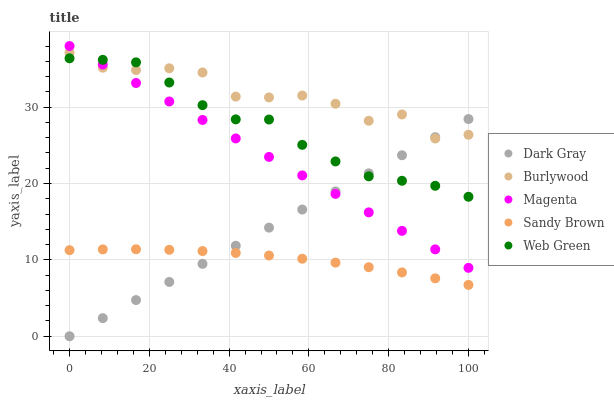Does Sandy Brown have the minimum area under the curve?
Answer yes or no. Yes. Does Burlywood have the maximum area under the curve?
Answer yes or no. Yes. Does Magenta have the minimum area under the curve?
Answer yes or no. No. Does Magenta have the maximum area under the curve?
Answer yes or no. No. Is Magenta the smoothest?
Answer yes or no. Yes. Is Burlywood the roughest?
Answer yes or no. Yes. Is Burlywood the smoothest?
Answer yes or no. No. Is Magenta the roughest?
Answer yes or no. No. Does Dark Gray have the lowest value?
Answer yes or no. Yes. Does Magenta have the lowest value?
Answer yes or no. No. Does Magenta have the highest value?
Answer yes or no. Yes. Does Burlywood have the highest value?
Answer yes or no. No. Is Sandy Brown less than Web Green?
Answer yes or no. Yes. Is Web Green greater than Sandy Brown?
Answer yes or no. Yes. Does Dark Gray intersect Sandy Brown?
Answer yes or no. Yes. Is Dark Gray less than Sandy Brown?
Answer yes or no. No. Is Dark Gray greater than Sandy Brown?
Answer yes or no. No. Does Sandy Brown intersect Web Green?
Answer yes or no. No. 